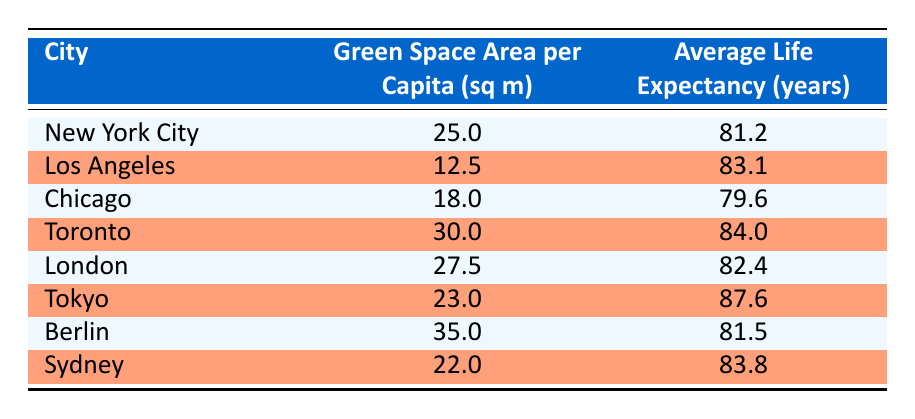What city has the highest average life expectancy? By inspecting the "Average Life Expectancy (years)" column, I can see that Tokyo has the highest value at 87.6 years.
Answer: Tokyo What is the green space area per capita in Chicago? I can locate the row for Chicago in the table and find that the value in the "Green Space Area per Capita (sq m)" column is 18.0.
Answer: 18.0 Which city has more green space area per capita: New York City or London? In the table, New York City has 25.0 sq m and London has 27.5 sq m. Since 27.5 is greater than 25.0, London has more green space per capita.
Answer: London What is the average life expectancy of cities with more than 20 sq m of green space? I need to first identify cities with more than 20 sq m: Toronto (30.0, 84.0), London (27.5, 82.4), Tokyo (23.0, 87.6), Berlin (35.0, 81.5), and Sydney (22.0, 83.8). There are 5 data points: (84.0 + 82.4 + 87.6 + 81.5 + 83.8) = 419.3. The average is 419.3 / 5 = 83.86, which I can round to 83.9.
Answer: 83.9 Is the average life expectancy higher in cities with more green space than 20 sq m than those with less? I identify cities with more than 20 sq m: Toronto, London, Tokyo, Berlin, and Sydney (average life expectancy: 83.9) and those with less: New York City, Los Angeles, Chicago (average life expectancy: 81.3). Since 83.9 is greater than 81.3, it’s true that cities with more green space have higher life expectancy.
Answer: Yes What is the difference in average life expectancy between Los Angeles and Berlin? From the table, I find that Los Angeles has an average life expectancy of 83.1 years and Berlin has 81.5 years. The difference is 83.1 - 81.5 = 1.6 years.
Answer: 1.6 Which city has the least green space area per capita? By checking the "Green Space Area per Capita (sq m)" column, I find Los Angeles has the lowest value at 12.5 sq m.
Answer: Los Angeles Is Toronto's green space area per capita greater than Tokyo's? I find that Toronto has 30.0 sq m while Tokyo has 23.0 sq m. Since 30.0 is greater than 23.0, it's true that Toronto's green space area per capita is greater.
Answer: Yes 